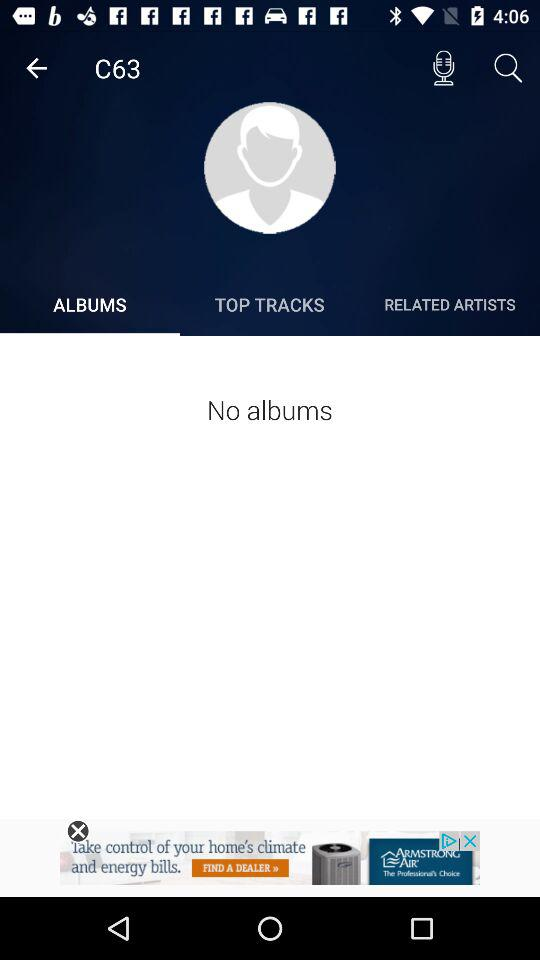How many top tracks are there?
When the provided information is insufficient, respond with <no answer>. <no answer> 